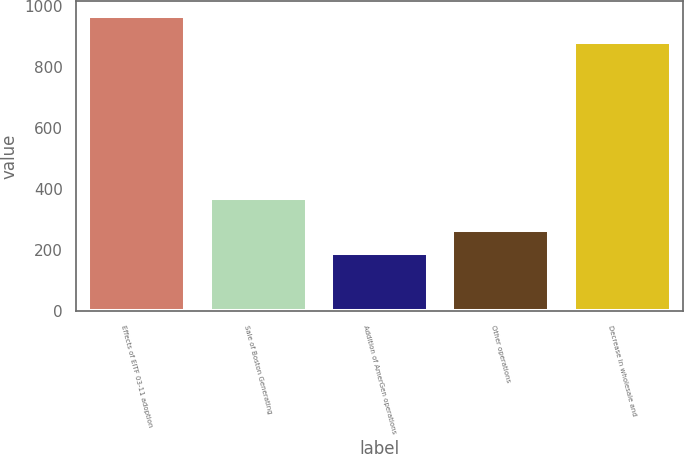Convert chart. <chart><loc_0><loc_0><loc_500><loc_500><bar_chart><fcel>Effects of EITF 03-11 adoption<fcel>Sale of Boston Generating<fcel>Addition of AmerGen operations<fcel>Other operations<fcel>Decrease in wholesale and<nl><fcel>966<fcel>370<fcel>189<fcel>267<fcel>880<nl></chart> 